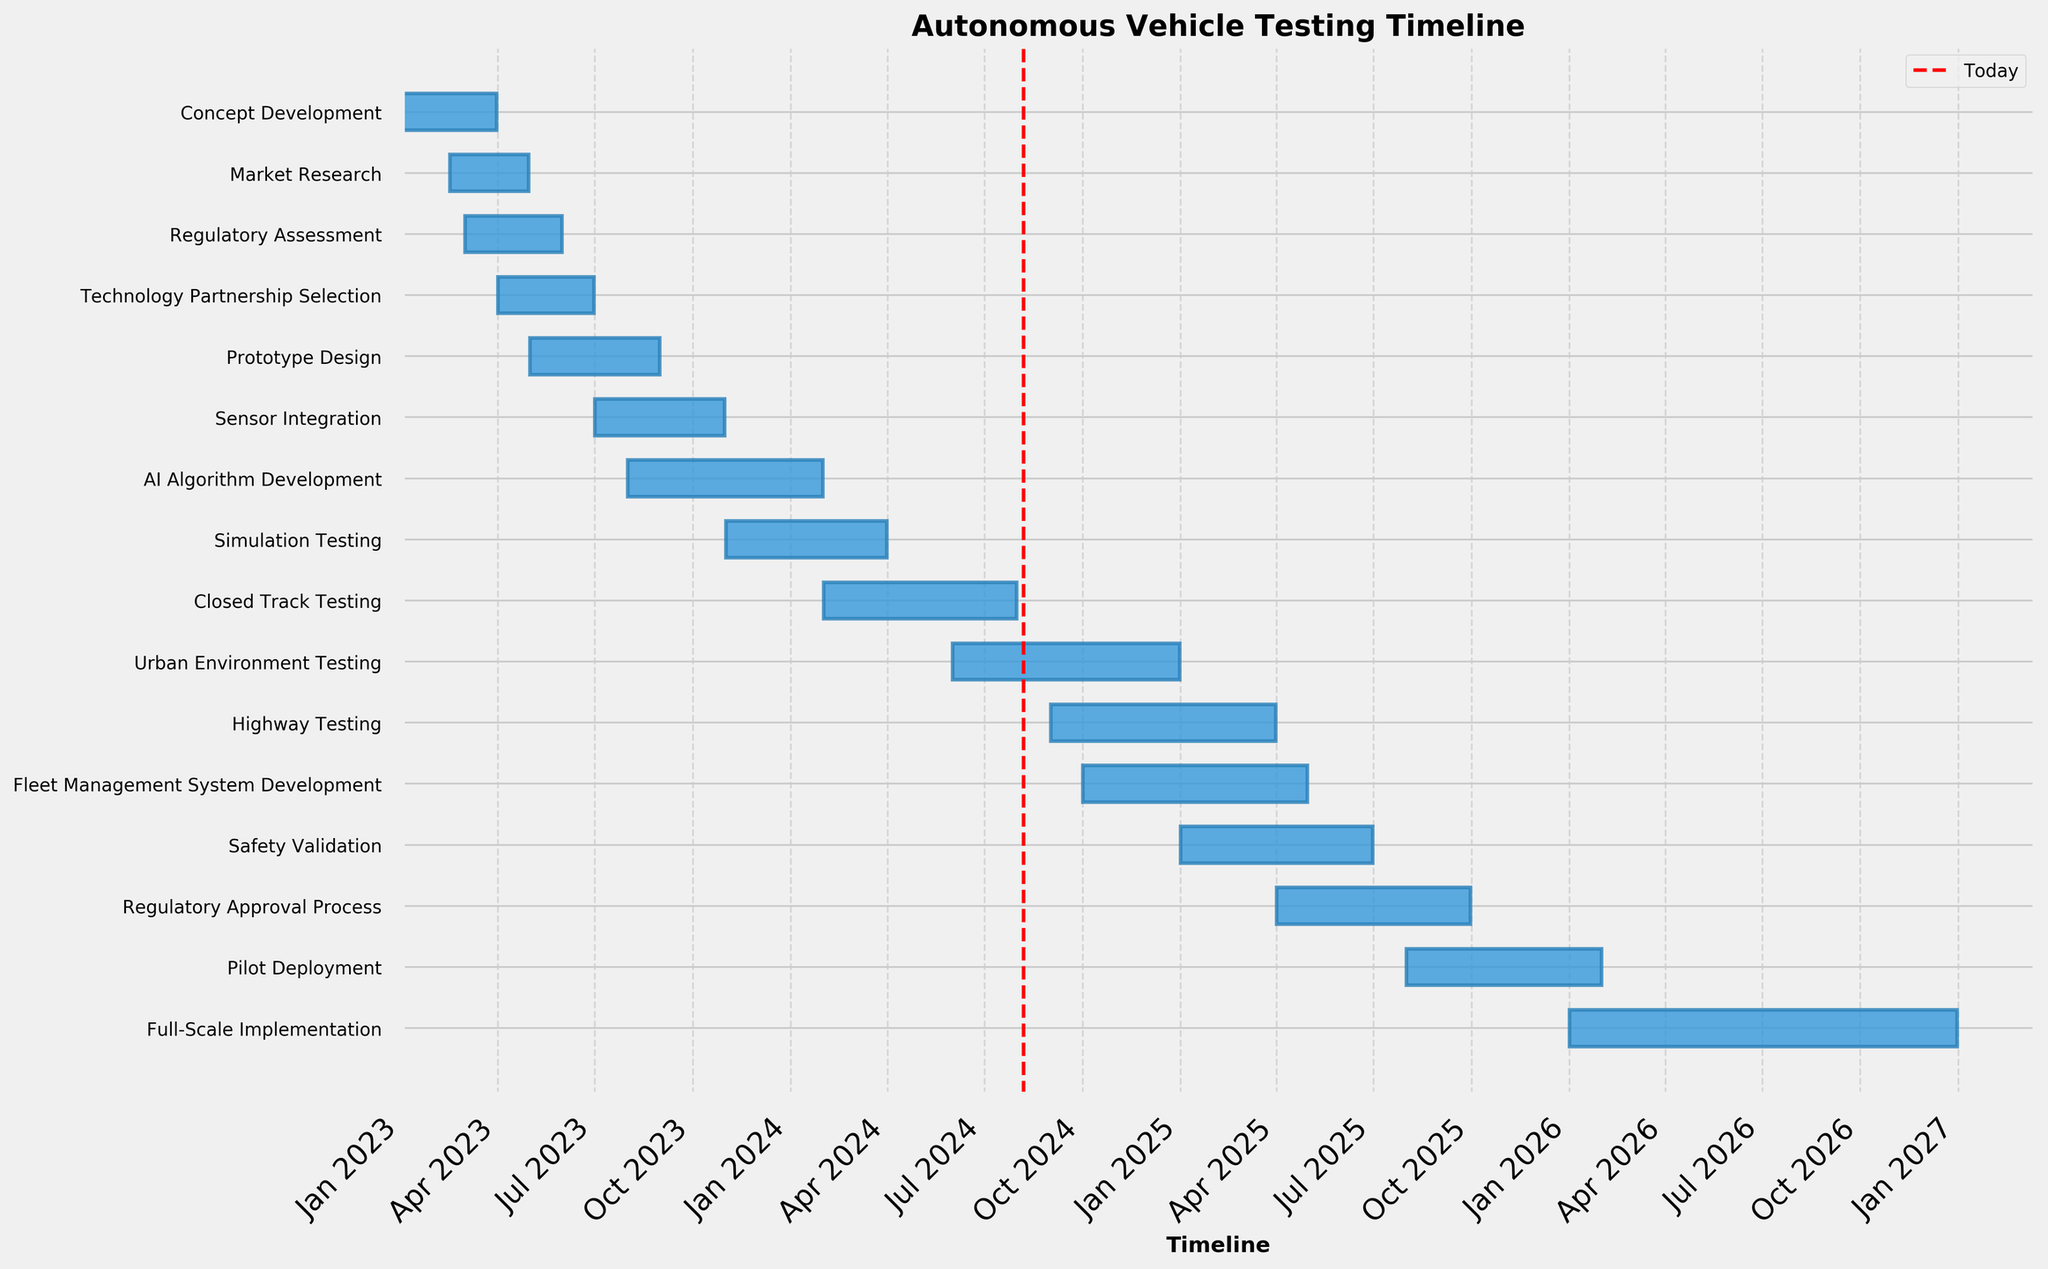What is the title of the plot? The title of the plot is displayed prominently at the top.
Answer: Autonomous Vehicle Testing Timeline Which task starts first according to the chart? The earliest task is the one with the earliest start date, visible at the top of the chart.
Answer: Concept Development During which months does the Prototype Design phase occur? By looking at the horizontal bar for Prototype Design, you can identify the start and end dates.
Answer: May 2023 to August 2023 Which tasks are running concurrently in April 2023? The Gantt chart shows overlapping bars, indicating concurrent tasks. By examining April 2023, you can see which tasks overlap.
Answer: Market Research and Regulatory Assessment How long does the AI Algorithm Development phase last? The duration can be calculated by looking at the start and end points of the corresponding bar on the chart.
Answer: 6 months Which phase ends last in the year 2024? By examining the end points of tasks that conclude in 2024, we can determine the latest one.
Answer: Urban Environment Testing What is the longest phase in the testing timeline? Measure the length of each bar, both visually and using data, to find the longest.
Answer: Full-Scale Implementation Comparing Closed Track Testing and Highway Testing, which starts first and by how many months? Identify the start dates of both phases and calculate the difference in months.
Answer: Closed Track Testing starts 7 months earlier Which tasks are scheduled to end in January 2025? Locate the bars that end in the specific month of January 2025.
Answer: AI Algorithm Development and Simulation Testing How many phases continue into the year 2025? Identify the bars that extend into the year 2025 to get a count.
Answer: Five phases 